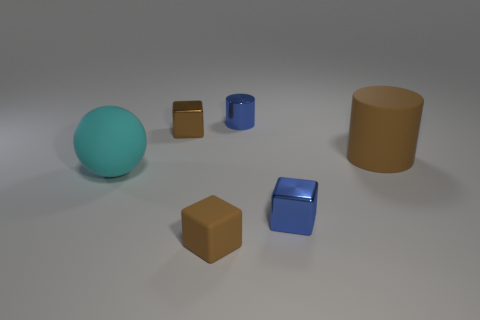Subtract all blue metallic cubes. How many cubes are left? 2 Subtract 2 cubes. How many cubes are left? 1 Subtract all blue cylinders. How many cylinders are left? 1 Subtract all blue cylinders. How many brown blocks are left? 2 Add 3 large matte spheres. How many large matte spheres exist? 4 Add 3 brown shiny blocks. How many objects exist? 9 Subtract 0 red spheres. How many objects are left? 6 Subtract all cylinders. How many objects are left? 4 Subtract all gray cylinders. Subtract all red blocks. How many cylinders are left? 2 Subtract all brown rubber cylinders. Subtract all cyan balls. How many objects are left? 4 